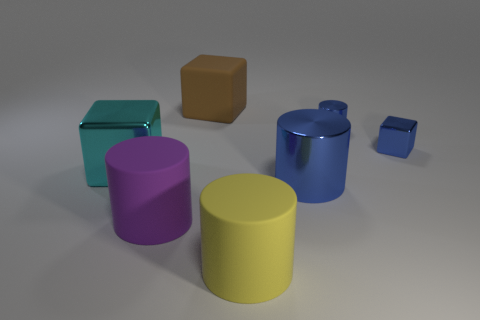There is a thing that is on the right side of the large yellow cylinder and on the left side of the tiny blue cylinder; what material is it?
Offer a very short reply. Metal. What is the color of the other small thing that is the same shape as the cyan thing?
Your response must be concise. Blue. Is there a yellow rubber cylinder right of the metallic cube on the right side of the large brown matte block?
Keep it short and to the point. No. What is the size of the brown object?
Your response must be concise. Large. The thing that is to the left of the big brown matte thing and behind the big purple object has what shape?
Provide a short and direct response. Cube. How many green things are large rubber cylinders or small metallic objects?
Offer a very short reply. 0. Does the rubber cylinder to the left of the big yellow rubber thing have the same size as the blue cylinder that is in front of the blue metallic cube?
Your response must be concise. Yes. What number of things are either blue matte cylinders or large yellow cylinders?
Offer a very short reply. 1. Is there another rubber object that has the same shape as the big cyan object?
Give a very brief answer. Yes. Are there fewer large red cubes than small blue shiny objects?
Offer a terse response. Yes. 